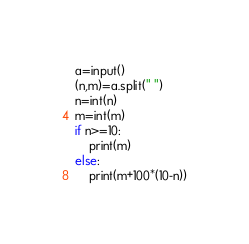<code> <loc_0><loc_0><loc_500><loc_500><_Python_>a=input()
(n,m)=a.split(" ")
n=int(n)
m=int(m)
if n>=10:
    print(m)
else:
    print(m+100*(10-n))</code> 